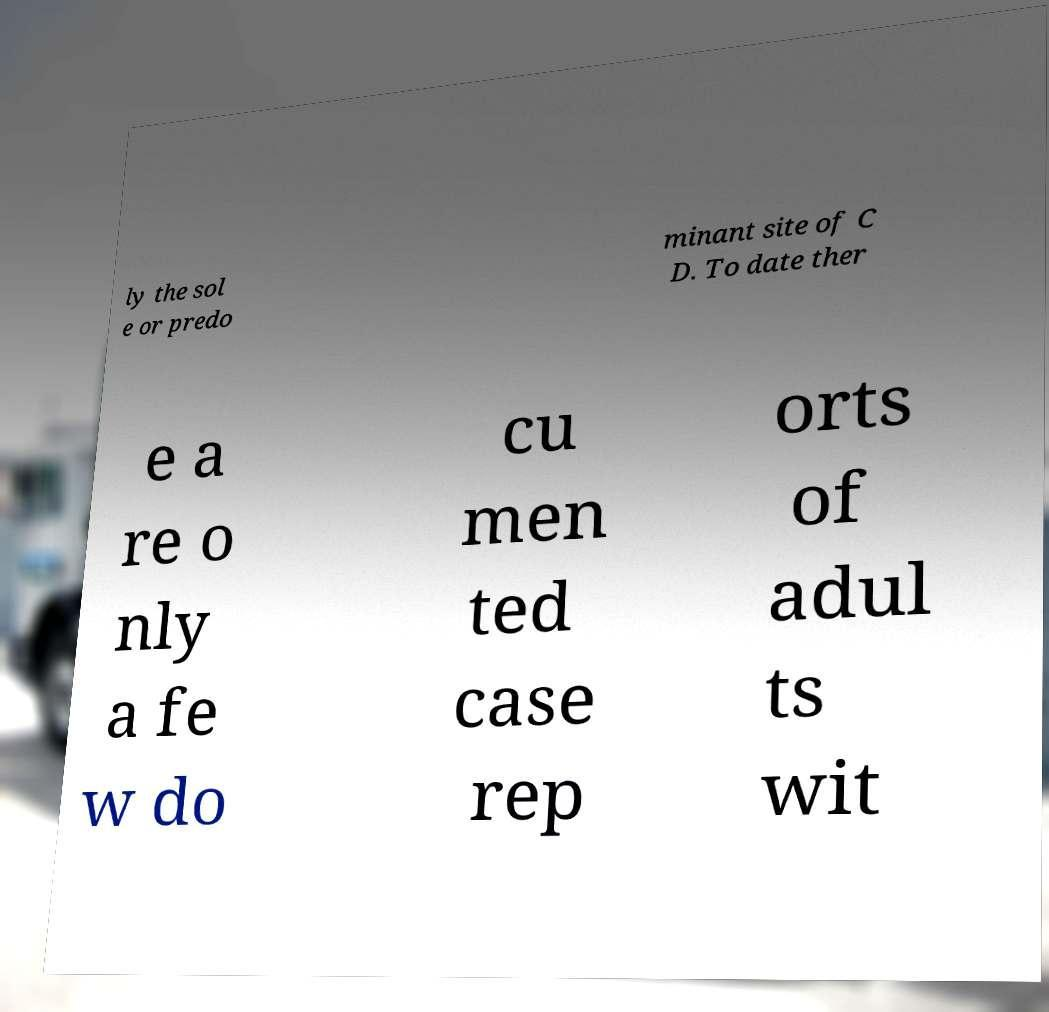Could you extract and type out the text from this image? ly the sol e or predo minant site of C D. To date ther e a re o nly a fe w do cu men ted case rep orts of adul ts wit 